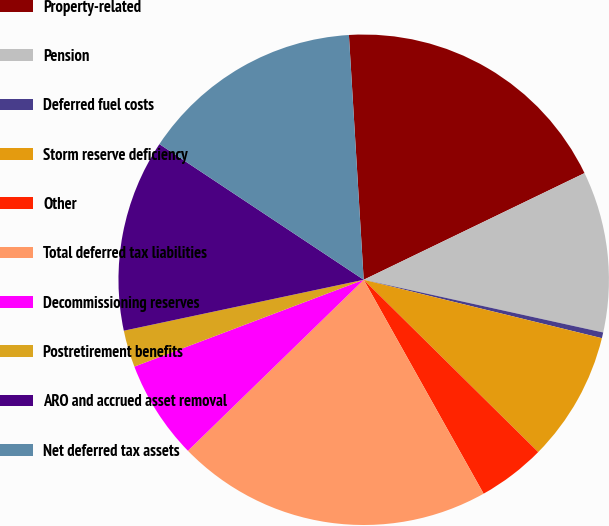<chart> <loc_0><loc_0><loc_500><loc_500><pie_chart><fcel>Property-related<fcel>Pension<fcel>Deferred fuel costs<fcel>Storm reserve deficiency<fcel>Other<fcel>Total deferred tax liabilities<fcel>Decommissioning reserves<fcel>Postretirement benefits<fcel>ARO and accrued asset removal<fcel>Net deferred tax assets<nl><fcel>18.8%<fcel>10.61%<fcel>0.38%<fcel>8.57%<fcel>4.47%<fcel>20.85%<fcel>6.52%<fcel>2.43%<fcel>12.66%<fcel>14.71%<nl></chart> 